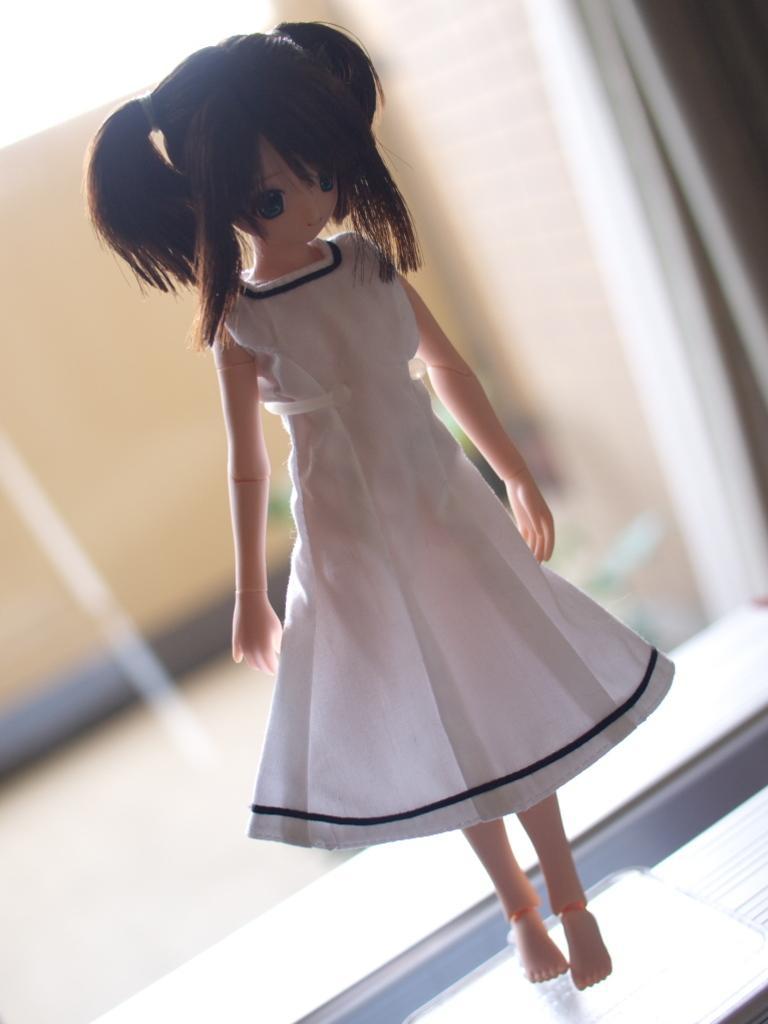In one or two sentences, can you explain what this image depicts? In this image I can see a doll and I can see this doll is wearing white colour dress. I can also see this image is little bit blurry in the background. 